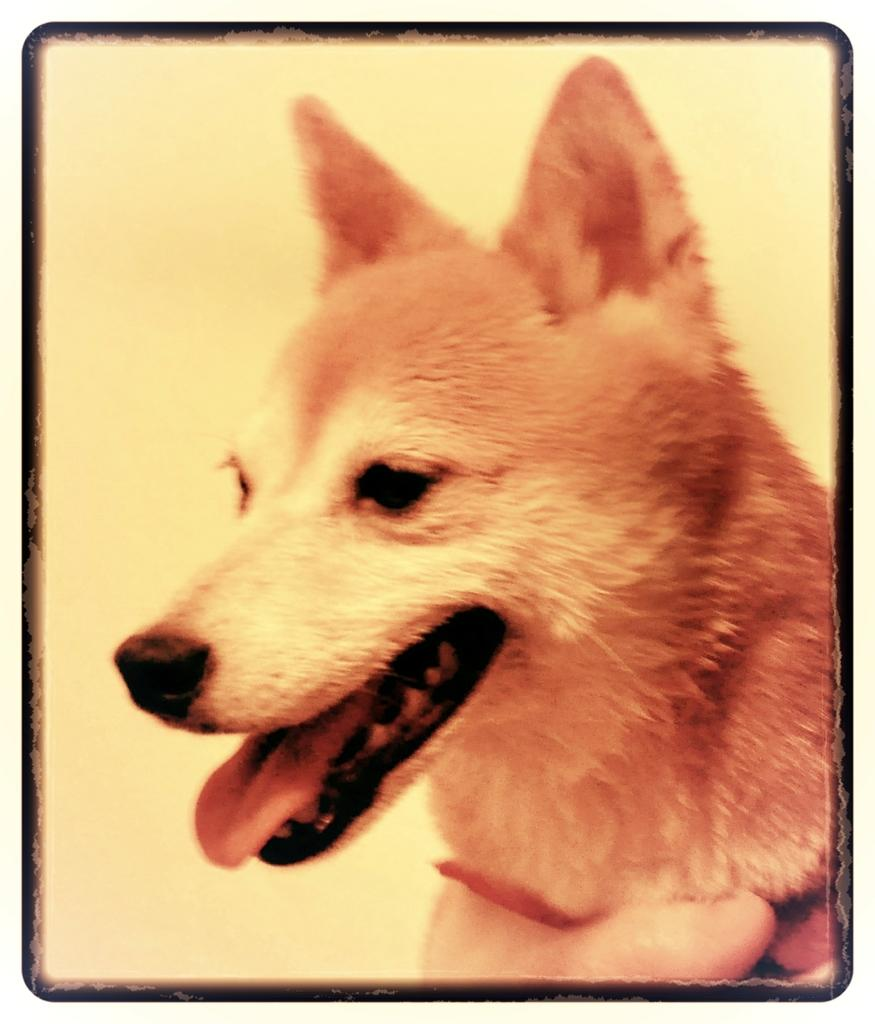What type of animal is in the image? There is a dog in the image. Can you describe any interaction between the dog and another subject in the image? The image shows a person's hand at the bottom, which might suggest some interaction between the dog and the person. What type of sweater is the dog wearing in the image? There is no sweater present in the image; the dog is not wearing any clothing. 